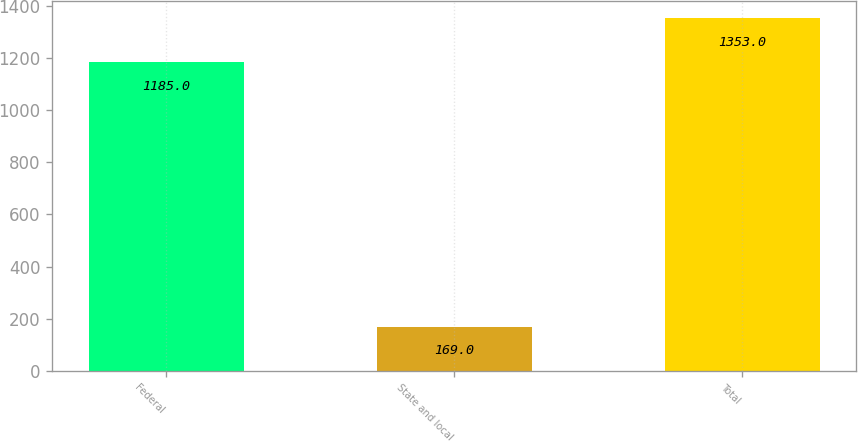Convert chart to OTSL. <chart><loc_0><loc_0><loc_500><loc_500><bar_chart><fcel>Federal<fcel>State and local<fcel>Total<nl><fcel>1185<fcel>169<fcel>1353<nl></chart> 